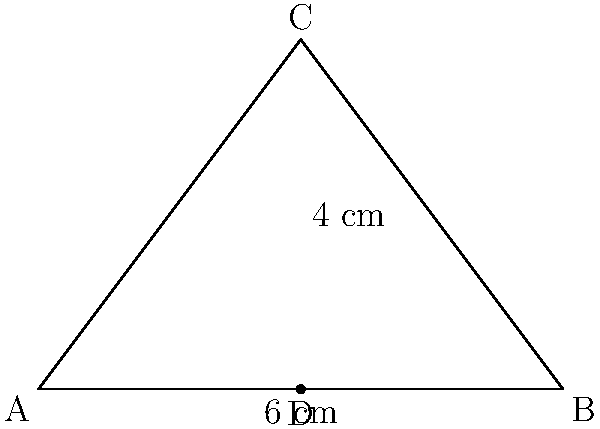You're designing a triangular display stand for showcasing Slum Village album covers. The base of the stand is 6 cm wide, and the height from the base to the apex is 4 cm. What is the area of this triangular display stand? To find the area of the triangular display stand, we can use the formula for the area of a triangle:

$$A = \frac{1}{2} \times base \times height$$

Given:
- Base (b) = 6 cm
- Height (h) = 4 cm

Let's substitute these values into the formula:

$$A = \frac{1}{2} \times 6 \text{ cm} \times 4 \text{ cm}$$

Now, let's calculate:

$$A = \frac{1}{2} \times 24 \text{ cm}^2 = 12 \text{ cm}^2$$

Therefore, the area of the triangular display stand is 12 square centimeters.
Answer: 12 cm² 